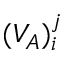Convert formula to latex. <formula><loc_0><loc_0><loc_500><loc_500>( V _ { A } ) _ { i } ^ { j }</formula> 